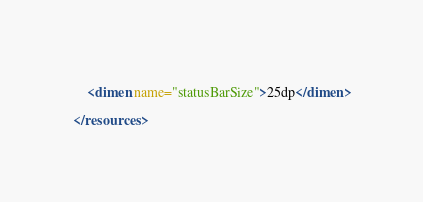Convert code to text. <code><loc_0><loc_0><loc_500><loc_500><_XML_>    
    <dimen name="statusBarSize">25dp</dimen>

</resources></code> 